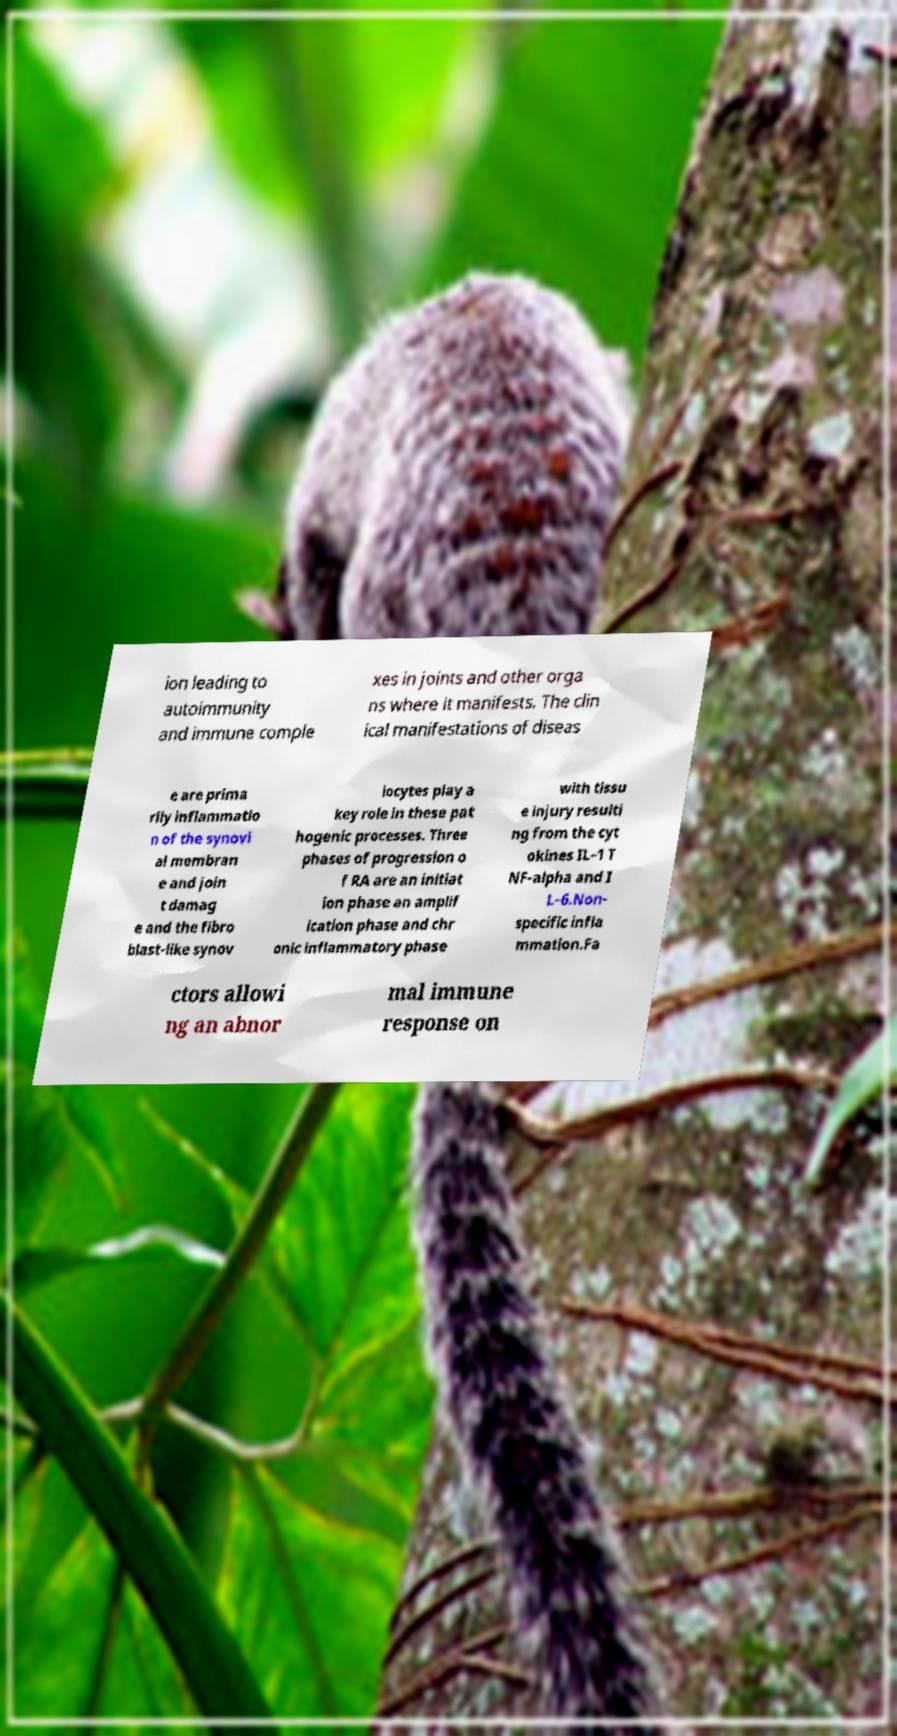Can you read and provide the text displayed in the image?This photo seems to have some interesting text. Can you extract and type it out for me? ion leading to autoimmunity and immune comple xes in joints and other orga ns where it manifests. The clin ical manifestations of diseas e are prima rily inflammatio n of the synovi al membran e and join t damag e and the fibro blast-like synov iocytes play a key role in these pat hogenic processes. Three phases of progression o f RA are an initiat ion phase an amplif ication phase and chr onic inflammatory phase with tissu e injury resulti ng from the cyt okines IL–1 T NF-alpha and I L–6.Non- specific infla mmation.Fa ctors allowi ng an abnor mal immune response on 